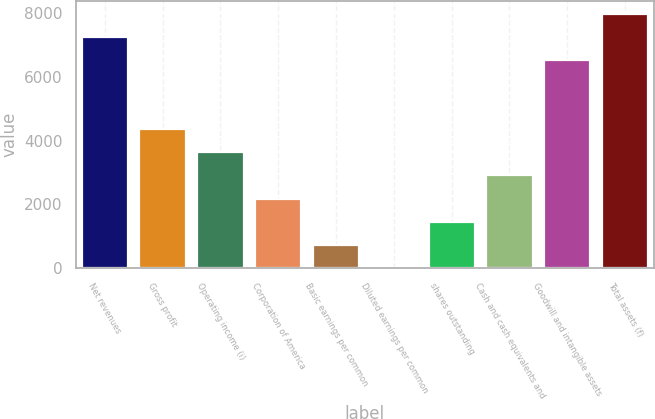Convert chart to OTSL. <chart><loc_0><loc_0><loc_500><loc_500><bar_chart><fcel>Net revenues<fcel>Gross profit<fcel>Operating income (i)<fcel>Corporation of America<fcel>Basic earnings per common<fcel>Diluted earnings per common<fcel>shares outstanding<fcel>Cash and cash equivalents and<fcel>Goodwill and intangible assets<fcel>Total assets (f)<nl><fcel>7262.81<fcel>4360.05<fcel>3634.36<fcel>2182.98<fcel>731.6<fcel>5.91<fcel>1457.29<fcel>2908.67<fcel>6537.12<fcel>7988.5<nl></chart> 